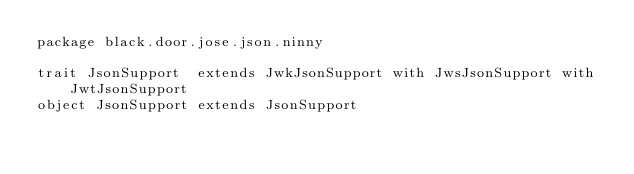Convert code to text. <code><loc_0><loc_0><loc_500><loc_500><_Scala_>package black.door.jose.json.ninny

trait JsonSupport  extends JwkJsonSupport with JwsJsonSupport with JwtJsonSupport
object JsonSupport extends JsonSupport
</code> 